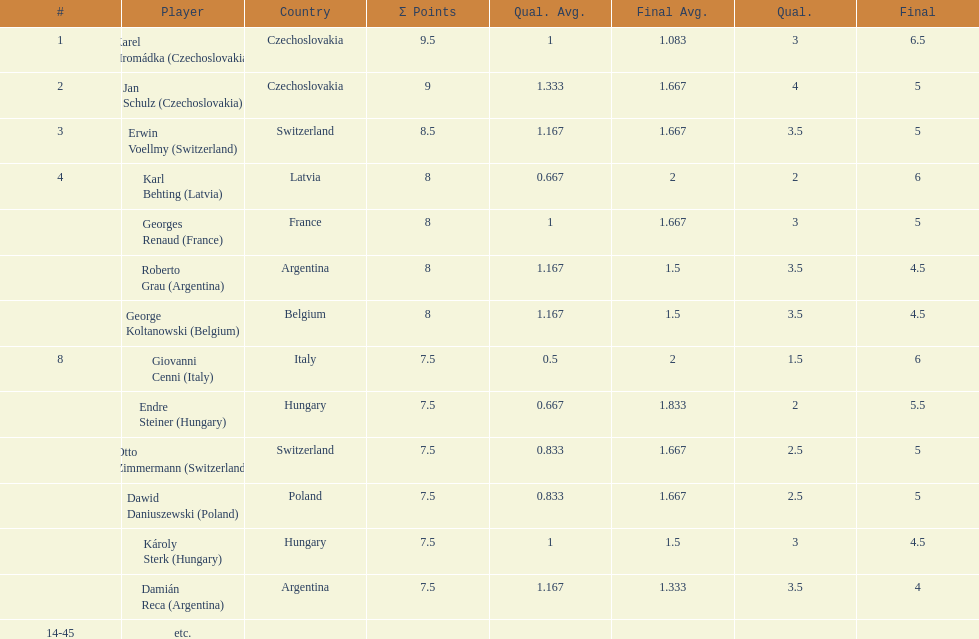How many players tied for 4th place? 4. Parse the full table. {'header': ['#', 'Player', 'Country', 'Σ Points', 'Qual. Avg.', 'Final Avg.', 'Qual.', 'Final'], 'rows': [['1', 'Karel Hromádka\xa0(Czechoslovakia)', 'Czechoslovakia', '9.5', '1', '1.083', '3', '6.5'], ['2', 'Jan Schulz\xa0(Czechoslovakia)', 'Czechoslovakia', '9', '1.333', '1.667', '4', '5'], ['3', 'Erwin Voellmy\xa0(Switzerland)', 'Switzerland', '8.5', '1.167', '1.667', '3.5', '5'], ['4', 'Karl Behting\xa0(Latvia)', 'Latvia', '8', '0.667', '2', '2', '6'], ['', 'Georges Renaud\xa0(France)', 'France', '8', '1', '1.667', '3', '5'], ['', 'Roberto Grau\xa0(Argentina)', 'Argentina', '8', '1.167', '1.5', '3.5', '4.5'], ['', 'George Koltanowski\xa0(Belgium)', 'Belgium', '8', '1.167', '1.5', '3.5', '4.5'], ['8', 'Giovanni Cenni\xa0(Italy)', 'Italy', '7.5', '0.5', '2', '1.5', '6'], ['', 'Endre Steiner\xa0(Hungary)', 'Hungary', '7.5', '0.667', '1.833', '2', '5.5'], ['', 'Otto Zimmermann\xa0(Switzerland)', 'Switzerland', '7.5', '0.833', '1.667', '2.5', '5'], ['', 'Dawid Daniuszewski\xa0(Poland)', 'Poland', '7.5', '0.833', '1.667', '2.5', '5'], ['', 'Károly Sterk\xa0(Hungary)', 'Hungary', '7.5', '1', '1.5', '3', '4.5'], ['', 'Damián Reca\xa0(Argentina)', 'Argentina', '7.5', '1.167', '1.333', '3.5', '4'], ['14-45', 'etc.', '', '', '', '', '', '']]} 